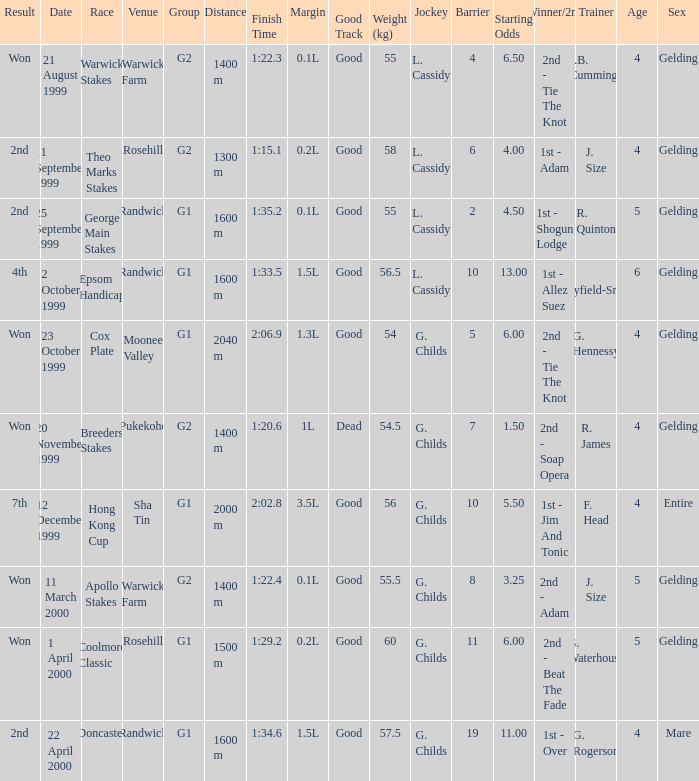List the weight for 56.5 kilograms. Epsom Handicap. 